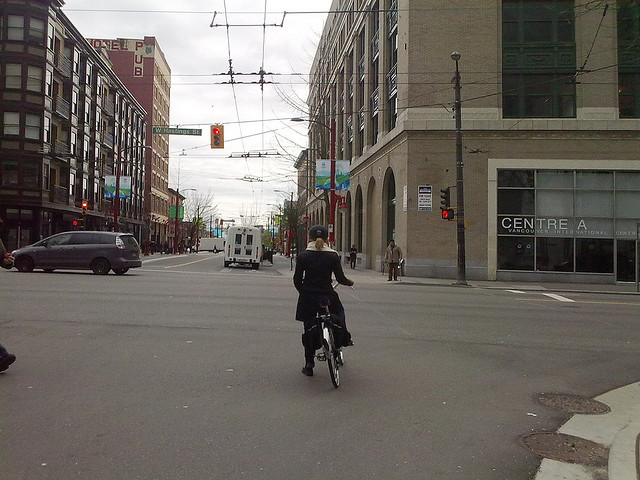<image>What sport is presented? I am not sure which sport is presented. It could be biking or bicycling. What sport is presented? I don't know what sport is presented. It can be both biking or bicycling. 